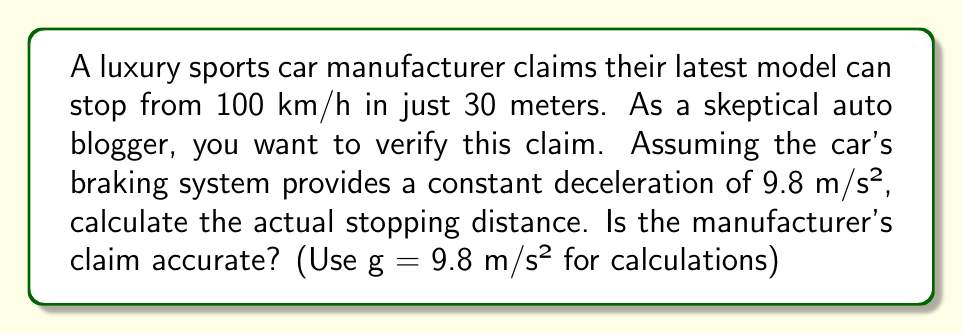Solve this math problem. Let's approach this step-by-step:

1) First, we need to convert the initial velocity from km/h to m/s:
   100 km/h = $100 * \frac{1000}{3600}$ m/s = 27.78 m/s

2) We'll use the equation for stopping distance with constant deceleration:
   $d = \frac{v^2}{2a}$

   Where:
   $d$ = stopping distance (m)
   $v$ = initial velocity (m/s)
   $a$ = deceleration (m/s²)

3) Plugging in our values:
   $d = \frac{(27.78)^2}{2(9.8)}$

4) Calculating:
   $d = \frac{771.73}{19.6} = 39.37$ meters

5) Rounding to two decimal places:
   $d \approx 39.37$ meters

The actual stopping distance is approximately 39.37 meters, which is significantly more than the claimed 30 meters.
Answer: 39.37 m; claim inaccurate 